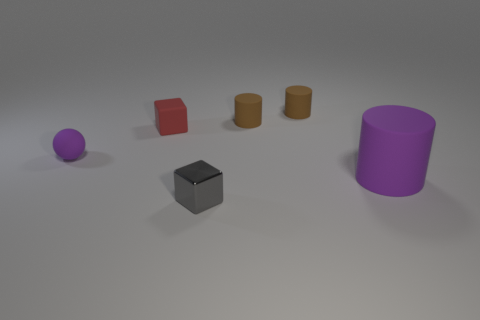Is the material of the purple sphere the same as the gray thing? The purple sphere and the gray cube appear to be rendered with different materials. The purple sphere has a slightly shiny, reflective surface indicative of a less diffusely reflective material, possibly with a higher specular value, while the gray cube seems to have a more matte, uniformly reflective surface, suggesting a different material with lower specularity. 